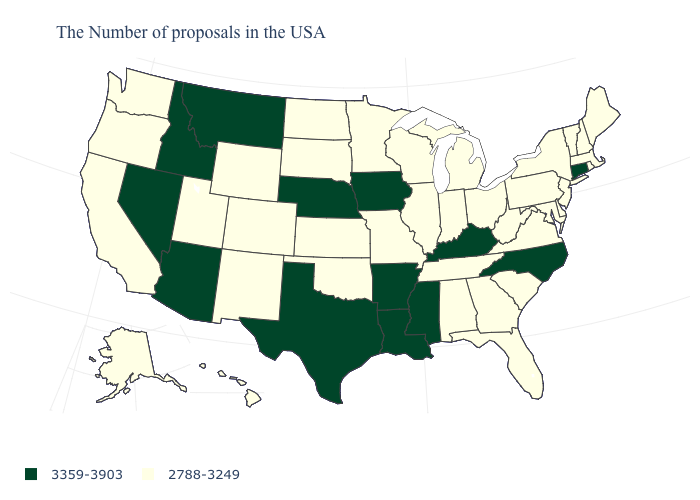What is the value of Florida?
Concise answer only. 2788-3249. What is the lowest value in the USA?
Give a very brief answer. 2788-3249. What is the value of South Dakota?
Be succinct. 2788-3249. What is the value of California?
Keep it brief. 2788-3249. Is the legend a continuous bar?
Be succinct. No. Which states have the lowest value in the USA?
Concise answer only. Maine, Massachusetts, Rhode Island, New Hampshire, Vermont, New York, New Jersey, Delaware, Maryland, Pennsylvania, Virginia, South Carolina, West Virginia, Ohio, Florida, Georgia, Michigan, Indiana, Alabama, Tennessee, Wisconsin, Illinois, Missouri, Minnesota, Kansas, Oklahoma, South Dakota, North Dakota, Wyoming, Colorado, New Mexico, Utah, California, Washington, Oregon, Alaska, Hawaii. Name the states that have a value in the range 2788-3249?
Quick response, please. Maine, Massachusetts, Rhode Island, New Hampshire, Vermont, New York, New Jersey, Delaware, Maryland, Pennsylvania, Virginia, South Carolina, West Virginia, Ohio, Florida, Georgia, Michigan, Indiana, Alabama, Tennessee, Wisconsin, Illinois, Missouri, Minnesota, Kansas, Oklahoma, South Dakota, North Dakota, Wyoming, Colorado, New Mexico, Utah, California, Washington, Oregon, Alaska, Hawaii. Which states have the highest value in the USA?
Be succinct. Connecticut, North Carolina, Kentucky, Mississippi, Louisiana, Arkansas, Iowa, Nebraska, Texas, Montana, Arizona, Idaho, Nevada. Does Nebraska have the highest value in the MidWest?
Keep it brief. Yes. What is the highest value in the South ?
Concise answer only. 3359-3903. Name the states that have a value in the range 2788-3249?
Short answer required. Maine, Massachusetts, Rhode Island, New Hampshire, Vermont, New York, New Jersey, Delaware, Maryland, Pennsylvania, Virginia, South Carolina, West Virginia, Ohio, Florida, Georgia, Michigan, Indiana, Alabama, Tennessee, Wisconsin, Illinois, Missouri, Minnesota, Kansas, Oklahoma, South Dakota, North Dakota, Wyoming, Colorado, New Mexico, Utah, California, Washington, Oregon, Alaska, Hawaii. Name the states that have a value in the range 3359-3903?
Answer briefly. Connecticut, North Carolina, Kentucky, Mississippi, Louisiana, Arkansas, Iowa, Nebraska, Texas, Montana, Arizona, Idaho, Nevada. Does the first symbol in the legend represent the smallest category?
Write a very short answer. No. 